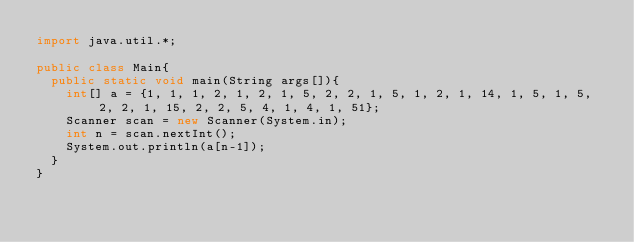<code> <loc_0><loc_0><loc_500><loc_500><_Java_>import java.util.*;
 
public class Main{
  public static void main(String args[]){
    int[] a = {1, 1, 1, 2, 1, 2, 1, 5, 2, 2, 1, 5, 1, 2, 1, 14, 1, 5, 1, 5, 2, 2, 1, 15, 2, 2, 5, 4, 1, 4, 1, 51};
    Scanner scan = new Scanner(System.in);
    int n = scan.nextInt();
    System.out.println(a[n-1]);
  }
}</code> 